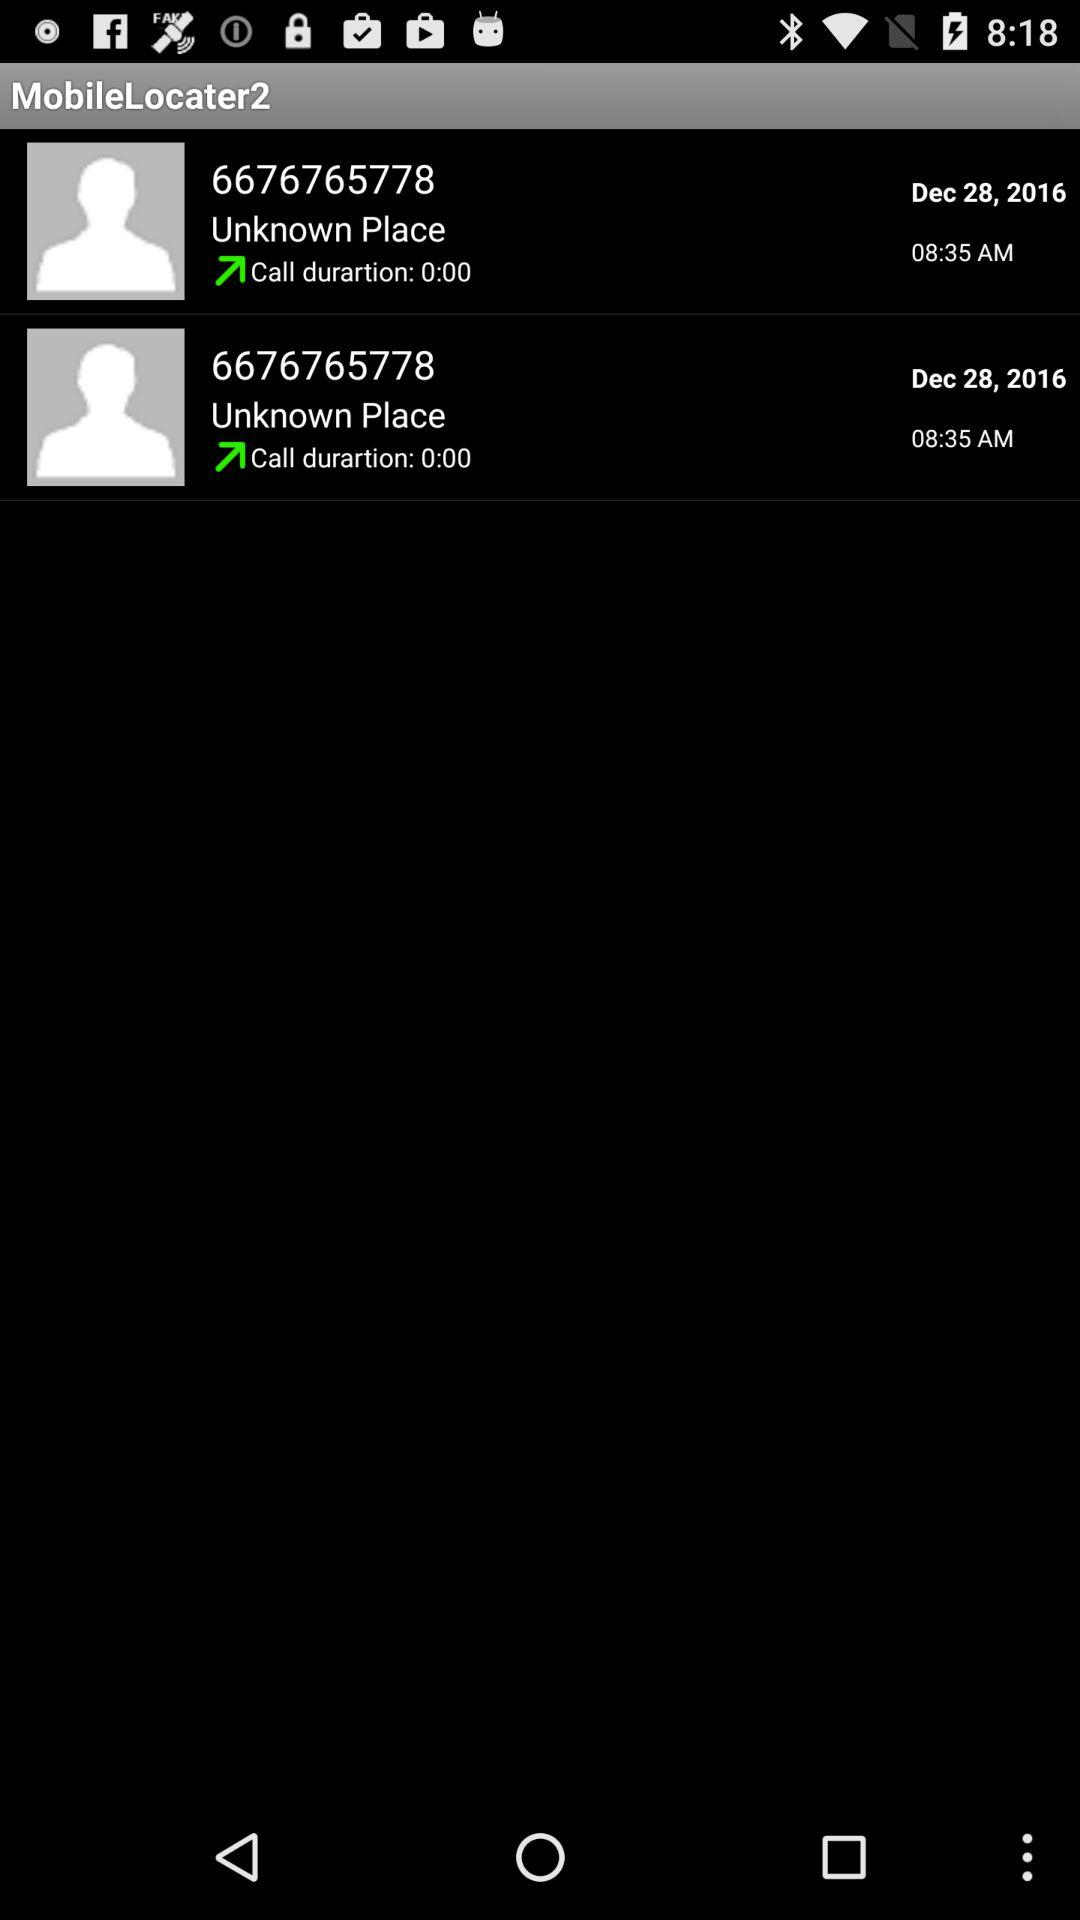How many calls do I have in my call history?
Answer the question using a single word or phrase. 2 